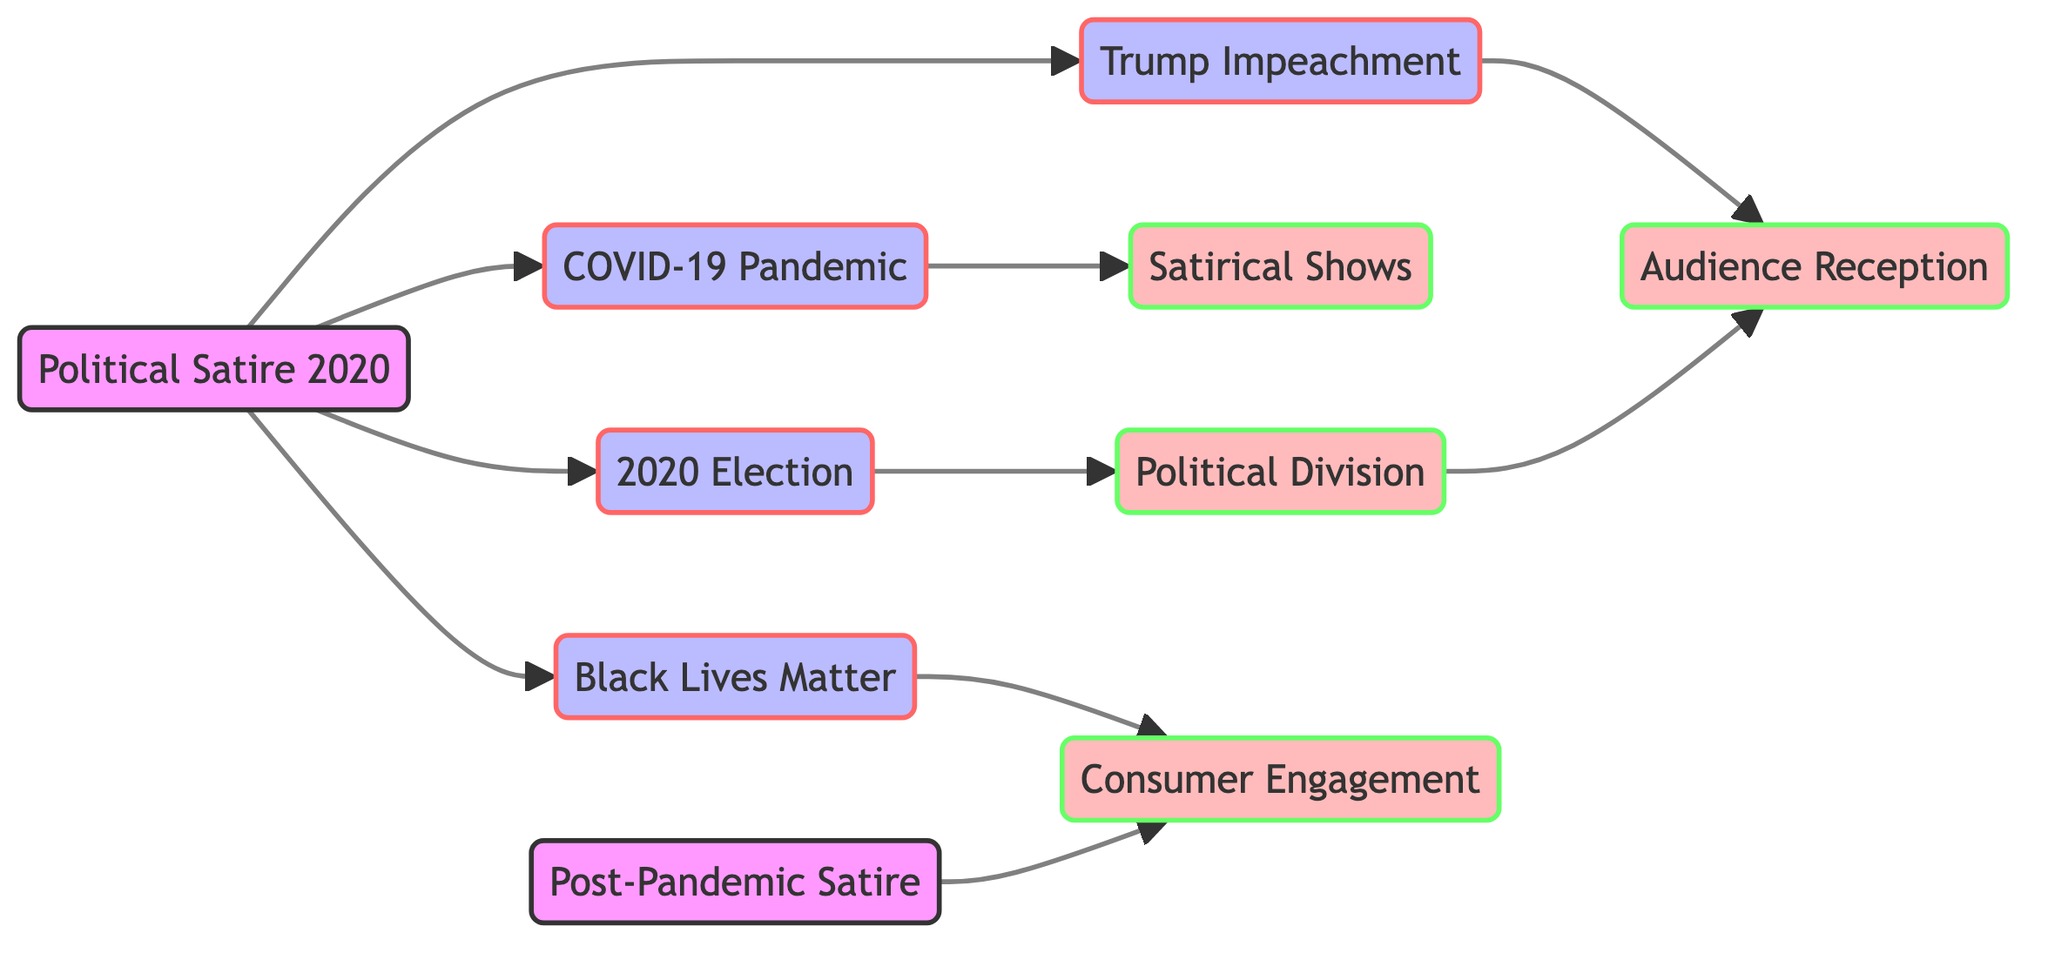What is the total number of nodes in the diagram? The diagram consists of 10 nodes: Political Satire 2020, Trump Impeachment, COVID-19 Pandemic, Black Lives Matter Movement, 2020 Presidential Election, Audience Reception, Satirical Shows, Increased Political Division, Consumer Engagement, and Post-Pandemic Satire Trends.
Answer: 10 Which node represents the response to the Trump Impeachment? The relationship shows that the Trump Impeachment node connects directly to the Audience Reception node, indicating the audience's response to it.
Answer: Audience Reception What theme connects the COVID-19 Pandemic with satirical content? The diagram indicates a direct edge from the COVID-19 Pandemic node to the Satirical Shows node, signifying that satirical content related to the pandemic emerged.
Answer: Satirical Shows How many edges are there in total? By counting the connections in the diagram, we see there are 10 edges: from Political Satire 2020 to Trump Impeachment, COVID-19 Pandemic, Black Lives Matter, and 2020 Presidential Election, and further connections to Audience Reception, Satirical Shows, Consumer Engagement, and increased Political Division.
Answer: 10 What is the relationship between the 2020 Presidential Election and Political Division? The edge from the 2020 Presidential Election node to the Increased Political Division node illustrates that the election contributed to this division.
Answer: Increased Political Division From which theme does post-pandemic satire trends lead to consumer engagement? The arrow from the Post-Pandemic Satire Trends node points towards the Consumer Engagement node, showing that trends in satire influenced consumer engagement in social issues.
Answer: Consumer Engagement Which event themes have direct connections to the Audience Reception node? The Audience Reception node connects directly to three themes: Trump Impeachment, Political Division, and the Black Lives Matter Movement, showing how these events shaped audience responses.
Answer: Trump Impeachment, Political Division, Black Lives Matter Movement What does the edge from Black Lives Matter Movement signify in the context of consumer interaction? The diagram shows an edge from the Black Lives Matter Movement to Consumer Engagement, indicating that the movement led to an increase in public engagement with social issues.
Answer: Consumer Engagement Which two themes contribute to the content of satirical shows regarding the pandemic? The diagram connects the COVID-19 Pandemic directly to Satirical Shows and shows that these themes are intertwined, suggesting that comedy reflected events during the pandemic.
Answer: COVID-19 Pandemic, Satirical Shows 